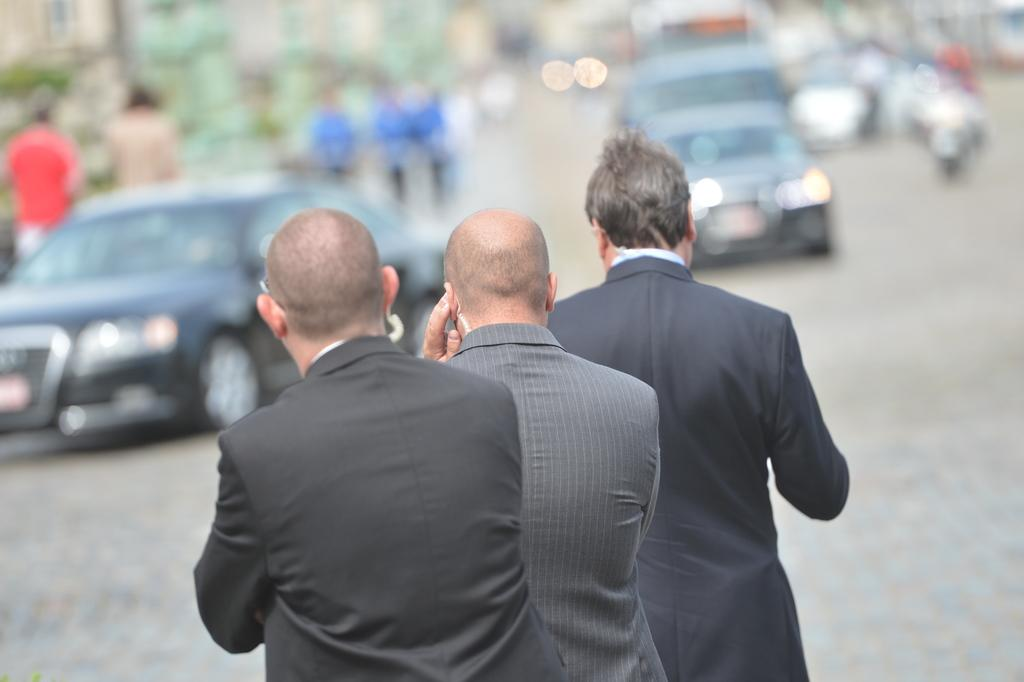How many people are at the bottom of the picture? There are three people at the bottom of the picture. Can you describe the background of the image? There are people, trees, and buildings in the background of the image. What else can be seen in the image? There are vehicles in the image. What type of shoes are the people wearing in the image? There is no information about the type of shoes the people are wearing in the image. 